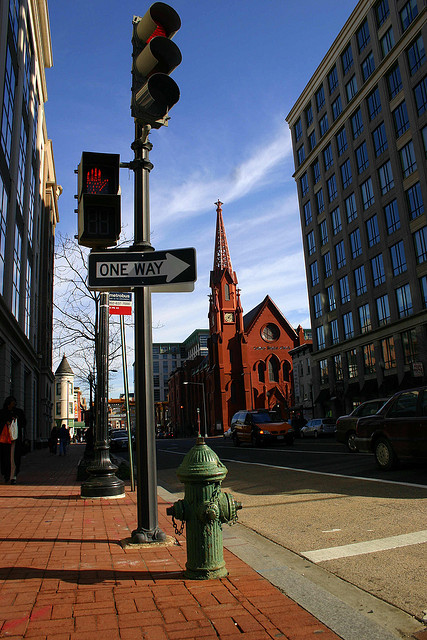What does the traffic light and one-way sign indicate about the rules of this road? The traffic light indicates that there is controlled vehicular traffic movement at this intersection, and the one-way sign shows that vehicles can only travel in the direction the sign is pointing. Together, they help regulate traffic flow for safety and efficiency. 